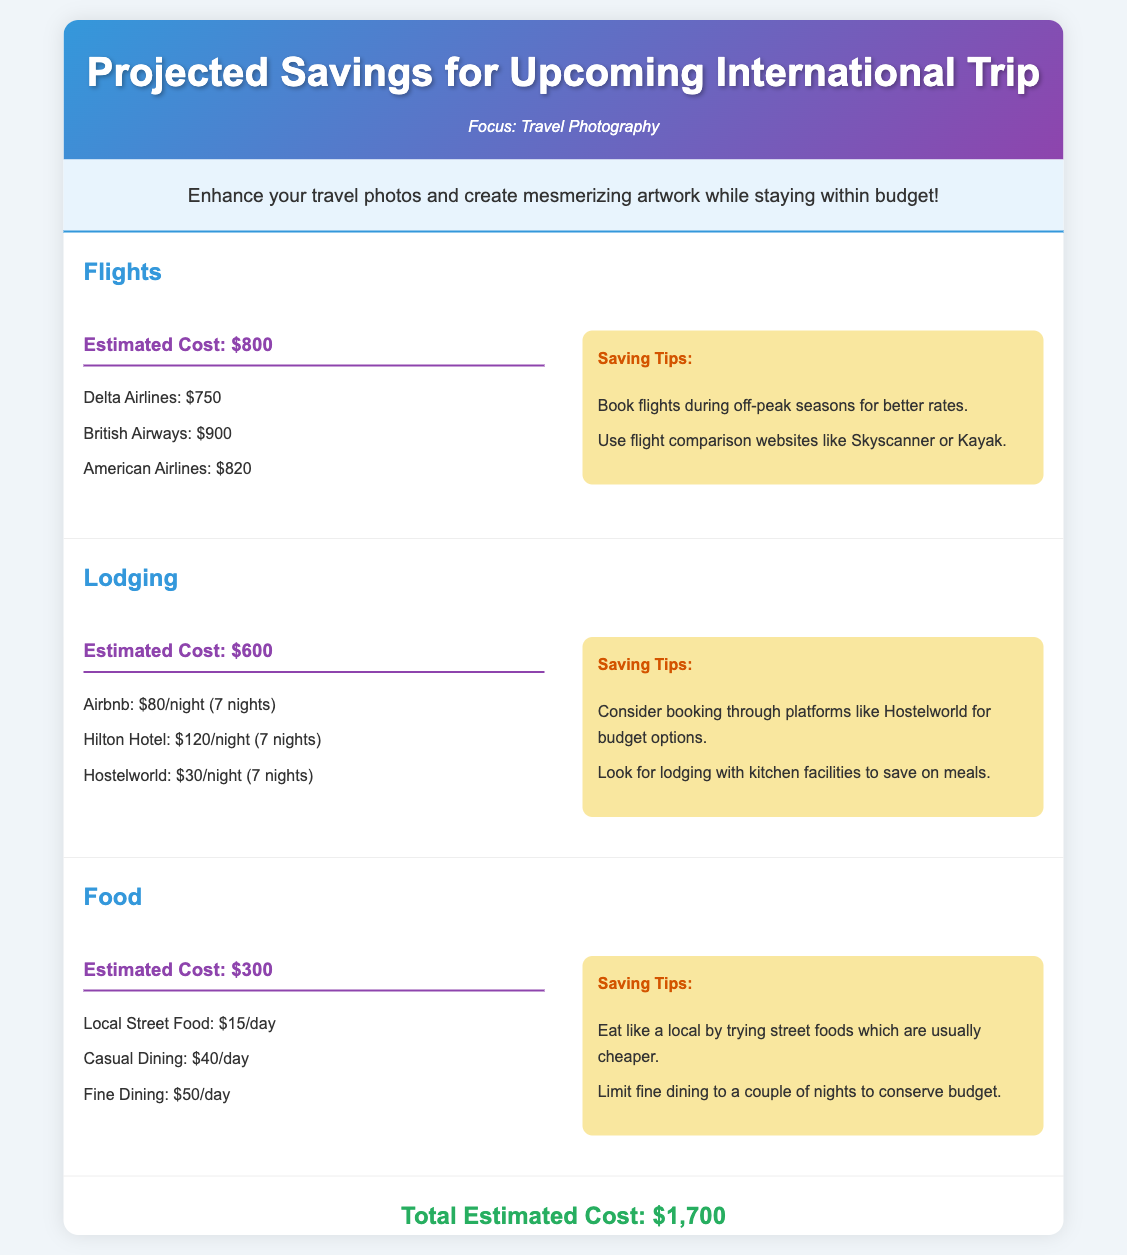What is the estimated cost for flights? The estimated cost for flights is provided in the document under the Flights category, which is $800.
Answer: $800 What are two airlines mentioned for flights? The document lists Delta Airlines and British Airways as options for flights.
Answer: Delta Airlines, British Airways How much is the cost for lodging per night at Airbnb? The expected price for lodging through Airbnb is specified in the Lodging section as $80 per night.
Answer: $80 What is the total estimated cost of the trip? The document summarizes the total estimated cost at the end, which adds up to $1,700.
Answer: $1,700 What day-to-day cost is associated with local street food? The cost for local street food is indicated in the Food category as $15 per day.
Answer: $15 What is one suggested tip for saving on flights? The document suggests booking flights during off-peak seasons for better rates as a saving tip.
Answer: Book flights during off-peak seasons How many nights are included in the lodging costs? The lodging costs consider a total of 7 nights, as mentioned in the calculation details.
Answer: 7 nights What is listed as a fine dining cost per day? The cost for fine dining is mentioned in the Food section as $50 per day.
Answer: $50 What platform is recommended for budget lodging options? The document recommends using Hostelworld for budget lodging options as stated in the saving tips.
Answer: Hostelworld 